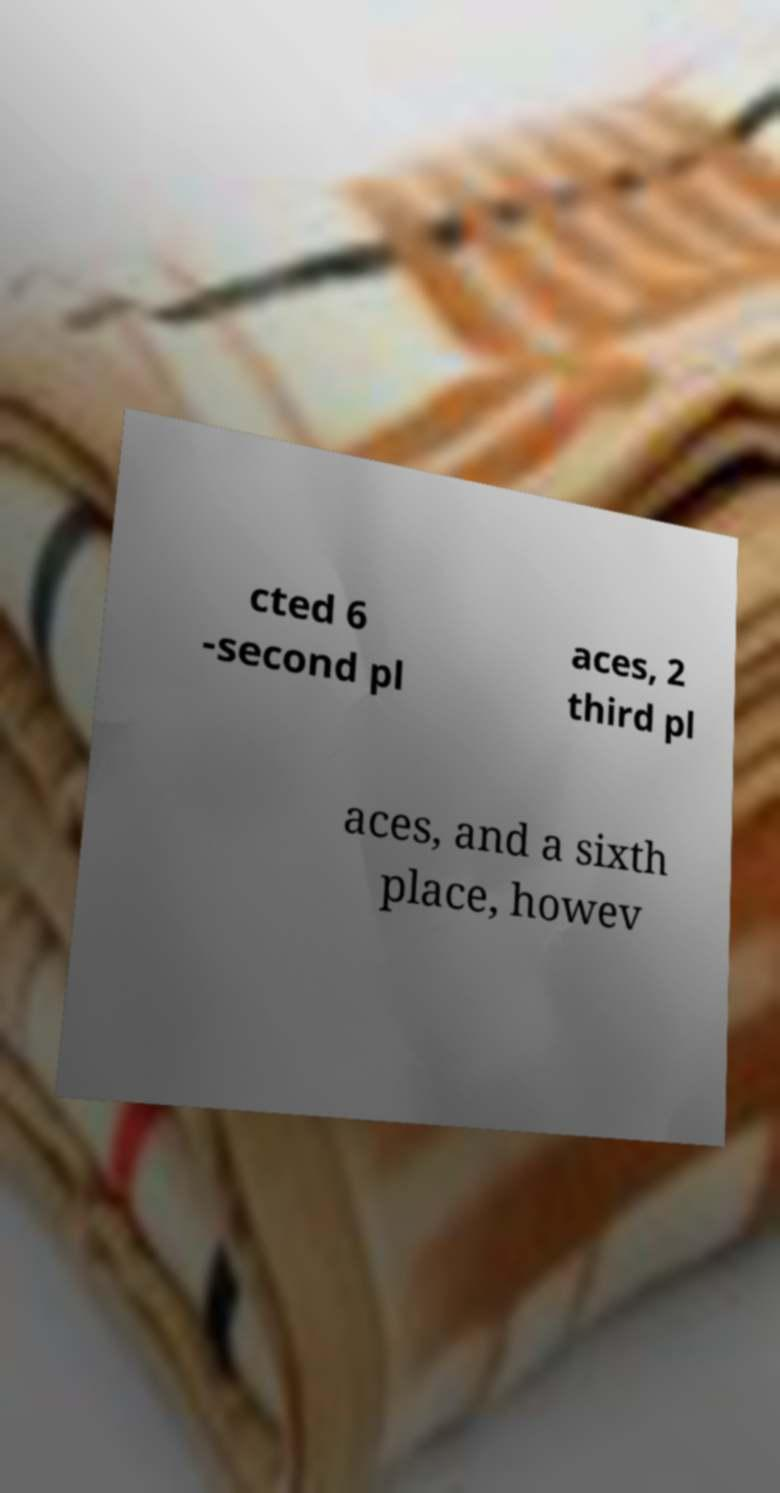Could you extract and type out the text from this image? cted 6 -second pl aces, 2 third pl aces, and a sixth place, howev 